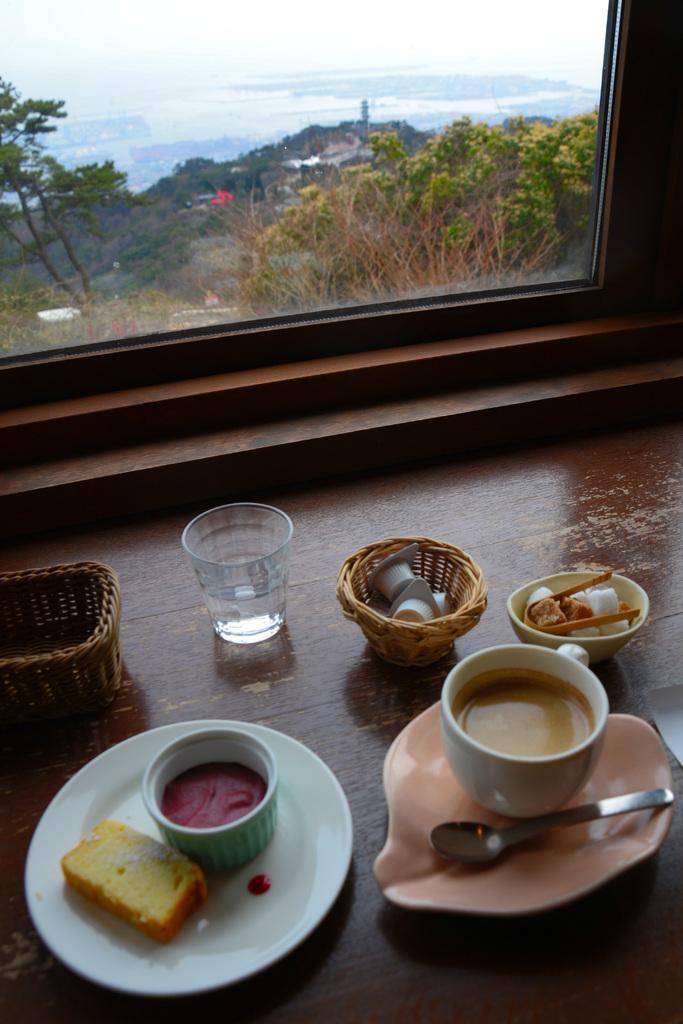Describe this image in one or two sentences. In this picture I can see the brown color surface in front and on it I see 2 baskets, 2 cups, plates on which there is food and a spoon and I see a glass and I see a bowl in which there is something and in the background I see the window through which I see number of trees. 